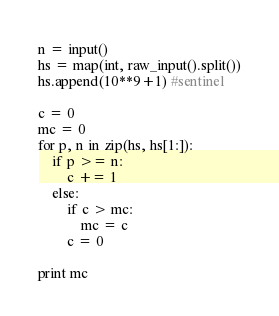<code> <loc_0><loc_0><loc_500><loc_500><_Python_>n = input()
hs = map(int, raw_input().split())
hs.append(10**9+1) #sentinel

c = 0
mc = 0
for p, n in zip(hs, hs[1:]):
	if p >= n:
		c += 1
	else:
		if c > mc:
			mc = c
		c = 0

print mc
</code> 